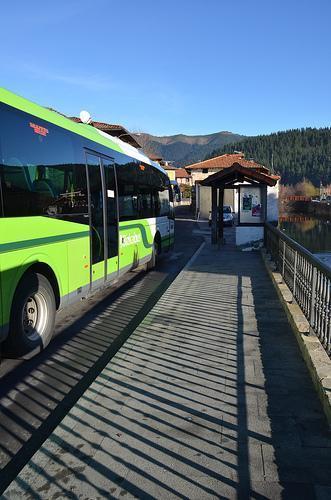How many buses are there?
Give a very brief answer. 1. 